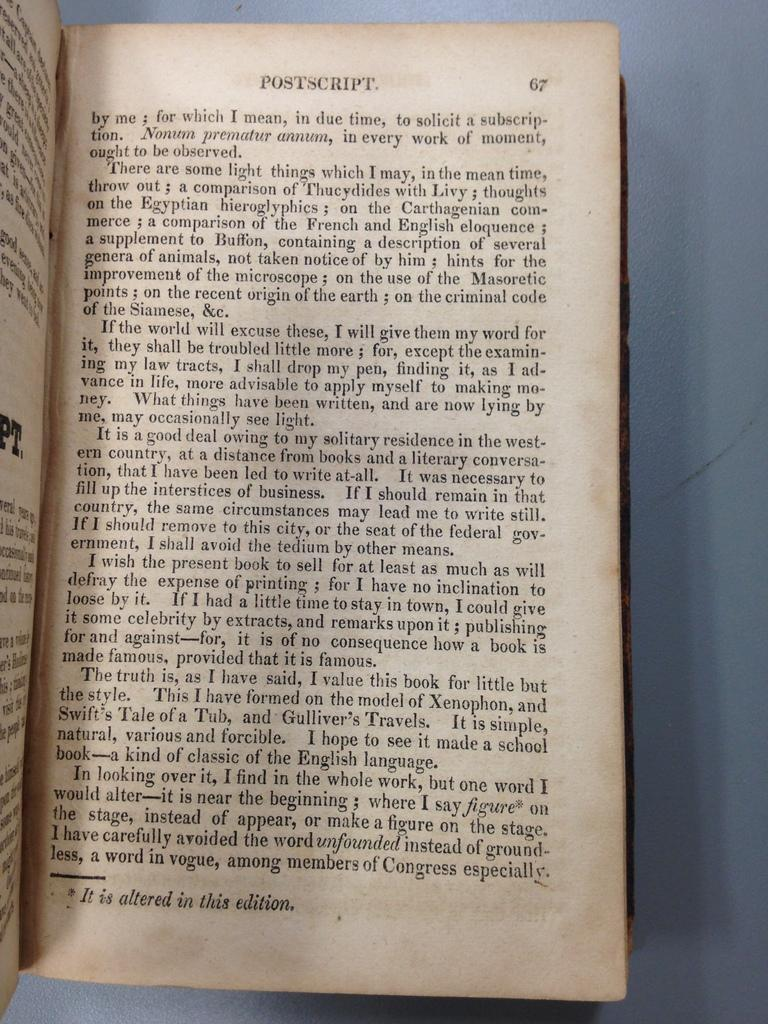<image>
Relay a brief, clear account of the picture shown. a book with the word 'postscript' typed at the top of a page 